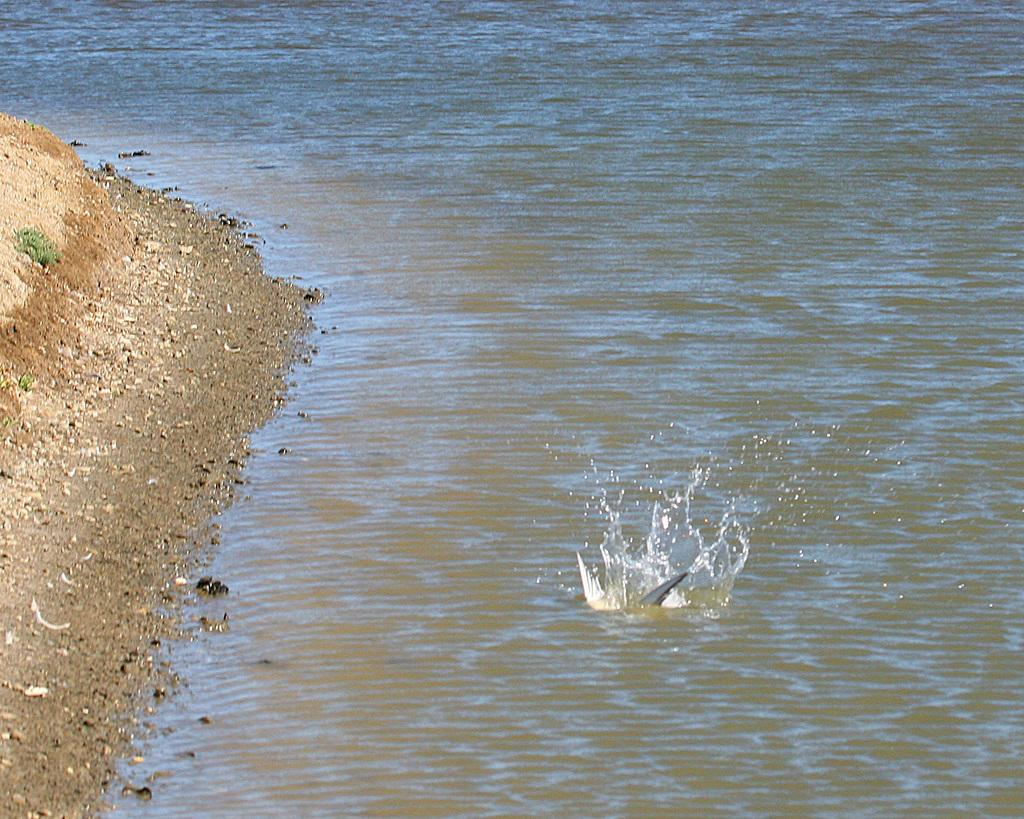Where was the image taken? The image was taken at the seashore. What can be seen in the image besides the seashore? There is water and sand visible in the image. On which side of the image is the sand located? The sand is located on the left side of the image. How many dogs can be seen playing on the mountain in the image? There are no dogs or mountains present in the image; it is taken at the seashore with water and sand visible. 